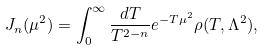Convert formula to latex. <formula><loc_0><loc_0><loc_500><loc_500>J _ { n } ( \mu ^ { 2 } ) = \int _ { 0 } ^ { \infty } \frac { d T } { T ^ { 2 - n } } e ^ { - T \mu ^ { 2 } } \rho ( T , \Lambda ^ { 2 } ) ,</formula> 